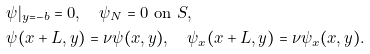<formula> <loc_0><loc_0><loc_500><loc_500>& \psi | _ { y = - b } = 0 , \quad \psi _ { N } = 0 \ \text {on} \ S , \\ & \psi ( x + L , y ) = \nu \psi ( x , y ) , \quad \psi _ { x } ( x + L , y ) = \nu \psi _ { x } ( x , y ) .</formula> 